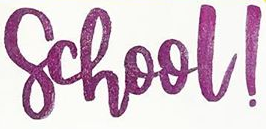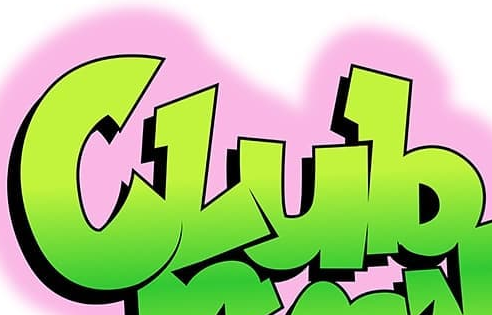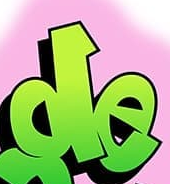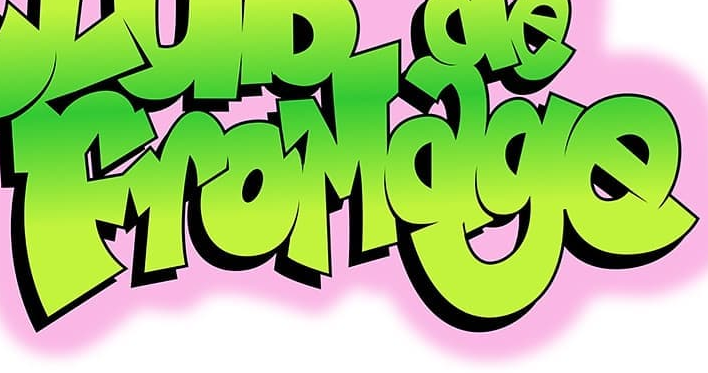What words can you see in these images in sequence, separated by a semicolon? school!; Club; de; FroMage 